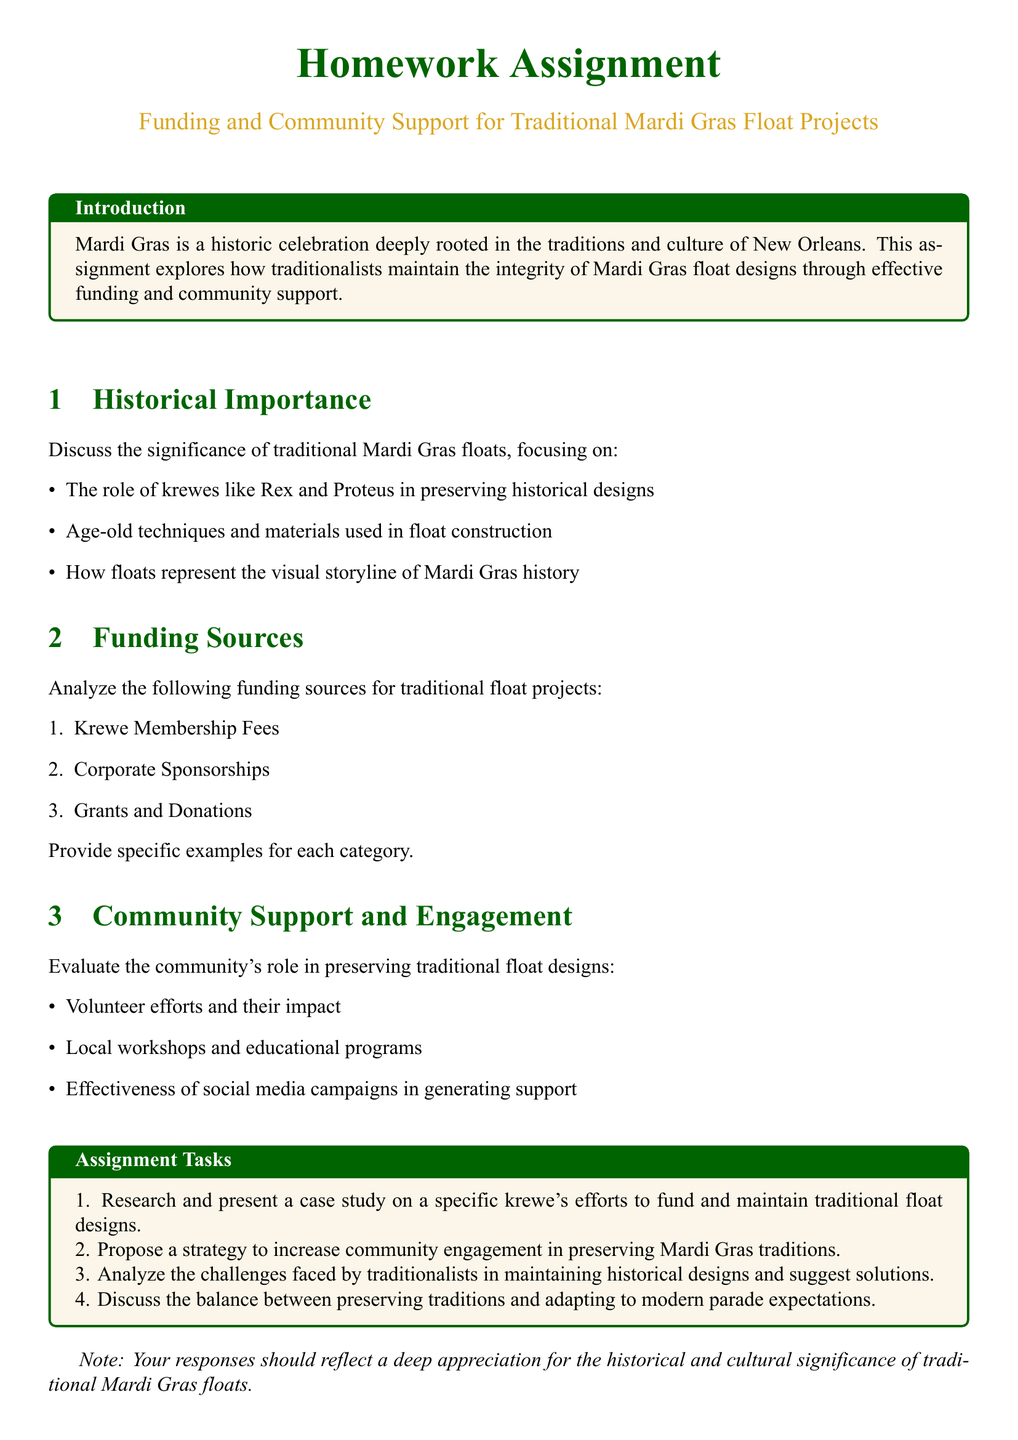What are the krewes mentioned in the document? The document mentions krewes like Rex and Proteus as significant in preserving historical designs.
Answer: Rex and Proteus What is one of the funding sources listed for traditional float projects? A funding source highlighted in the document is Krewe Membership Fees.
Answer: Krewe Membership Fees What is the primary focus of the community support section? The community support section evaluates the community's role in preserving traditional float designs.
Answer: Preserving traditional float designs Which color is used for section titles in the document? Section titles in the document are formatted in dark green color.
Answer: Dark green How many assignment tasks are listed in the document? The document outlines four assignment tasks related to Mardi Gras float projects.
Answer: Four What is the significance of floats described in the historical importance section? Floats represent the visual storyline of Mardi Gras history according to the document.
Answer: Visual storyline of Mardi Gras history What type of campaigns are evaluated for their effectiveness in generating support? The document discusses the effectiveness of social media campaigns in generating community support.
Answer: Social media campaigns What is the tone suggested for responses in the assignment note? The assignment note suggests a tone that reflects a deep appreciation for the historical and cultural significance of traditional Mardi Gras floats.
Answer: Deep appreciation 